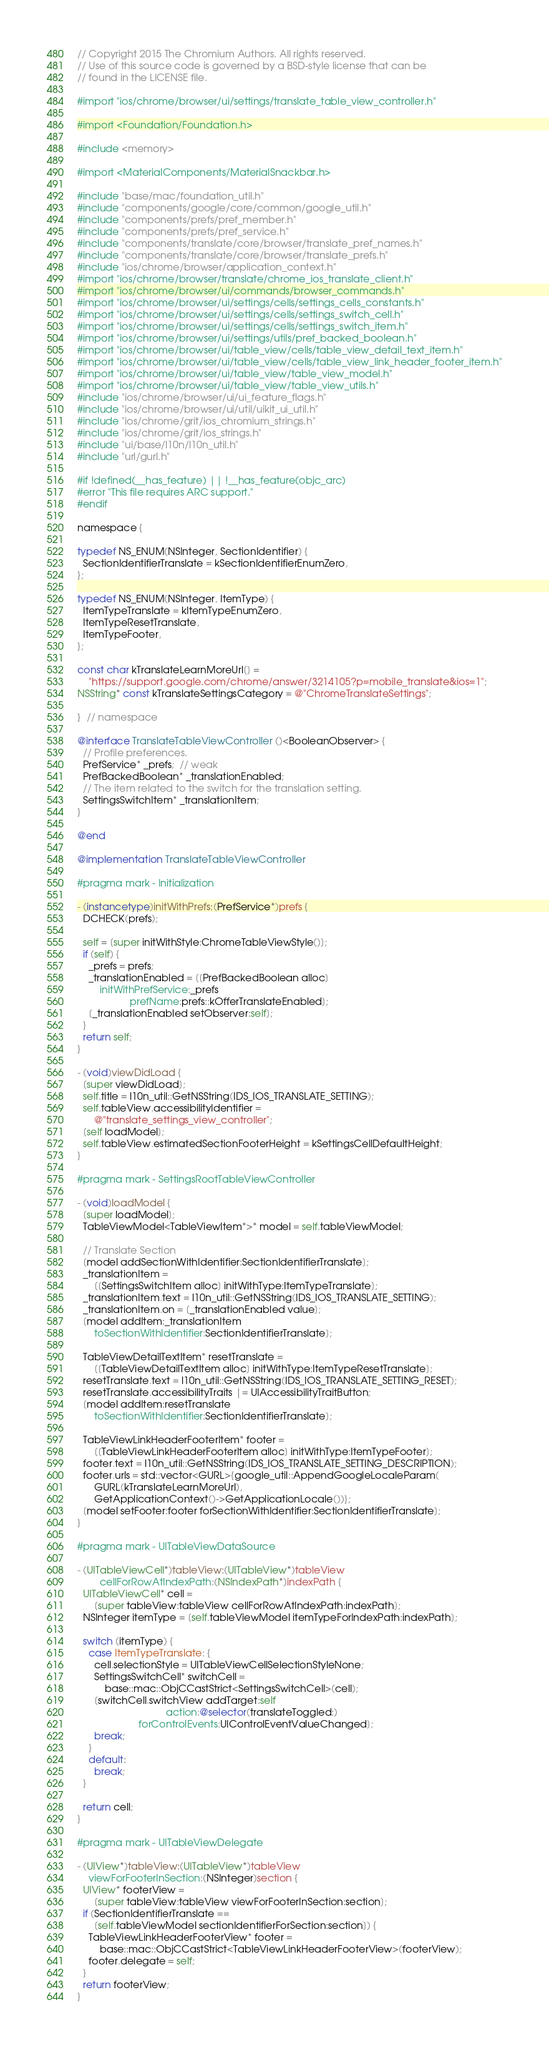Convert code to text. <code><loc_0><loc_0><loc_500><loc_500><_ObjectiveC_>// Copyright 2015 The Chromium Authors. All rights reserved.
// Use of this source code is governed by a BSD-style license that can be
// found in the LICENSE file.

#import "ios/chrome/browser/ui/settings/translate_table_view_controller.h"

#import <Foundation/Foundation.h>

#include <memory>

#import <MaterialComponents/MaterialSnackbar.h>

#include "base/mac/foundation_util.h"
#include "components/google/core/common/google_util.h"
#include "components/prefs/pref_member.h"
#include "components/prefs/pref_service.h"
#include "components/translate/core/browser/translate_pref_names.h"
#include "components/translate/core/browser/translate_prefs.h"
#include "ios/chrome/browser/application_context.h"
#import "ios/chrome/browser/translate/chrome_ios_translate_client.h"
#import "ios/chrome/browser/ui/commands/browser_commands.h"
#import "ios/chrome/browser/ui/settings/cells/settings_cells_constants.h"
#import "ios/chrome/browser/ui/settings/cells/settings_switch_cell.h"
#import "ios/chrome/browser/ui/settings/cells/settings_switch_item.h"
#import "ios/chrome/browser/ui/settings/utils/pref_backed_boolean.h"
#import "ios/chrome/browser/ui/table_view/cells/table_view_detail_text_item.h"
#import "ios/chrome/browser/ui/table_view/cells/table_view_link_header_footer_item.h"
#import "ios/chrome/browser/ui/table_view/table_view_model.h"
#import "ios/chrome/browser/ui/table_view/table_view_utils.h"
#include "ios/chrome/browser/ui/ui_feature_flags.h"
#include "ios/chrome/browser/ui/util/uikit_ui_util.h"
#include "ios/chrome/grit/ios_chromium_strings.h"
#include "ios/chrome/grit/ios_strings.h"
#include "ui/base/l10n/l10n_util.h"
#include "url/gurl.h"

#if !defined(__has_feature) || !__has_feature(objc_arc)
#error "This file requires ARC support."
#endif

namespace {

typedef NS_ENUM(NSInteger, SectionIdentifier) {
  SectionIdentifierTranslate = kSectionIdentifierEnumZero,
};

typedef NS_ENUM(NSInteger, ItemType) {
  ItemTypeTranslate = kItemTypeEnumZero,
  ItemTypeResetTranslate,
  ItemTypeFooter,
};

const char kTranslateLearnMoreUrl[] =
    "https://support.google.com/chrome/answer/3214105?p=mobile_translate&ios=1";
NSString* const kTranslateSettingsCategory = @"ChromeTranslateSettings";

}  // namespace

@interface TranslateTableViewController ()<BooleanObserver> {
  // Profile preferences.
  PrefService* _prefs;  // weak
  PrefBackedBoolean* _translationEnabled;
  // The item related to the switch for the translation setting.
  SettingsSwitchItem* _translationItem;
}

@end

@implementation TranslateTableViewController

#pragma mark - Initialization

- (instancetype)initWithPrefs:(PrefService*)prefs {
  DCHECK(prefs);

  self = [super initWithStyle:ChromeTableViewStyle()];
  if (self) {
    _prefs = prefs;
    _translationEnabled = [[PrefBackedBoolean alloc]
        initWithPrefService:_prefs
                   prefName:prefs::kOfferTranslateEnabled];
    [_translationEnabled setObserver:self];
  }
  return self;
}

- (void)viewDidLoad {
  [super viewDidLoad];
  self.title = l10n_util::GetNSString(IDS_IOS_TRANSLATE_SETTING);
  self.tableView.accessibilityIdentifier =
      @"translate_settings_view_controller";
  [self loadModel];
  self.tableView.estimatedSectionFooterHeight = kSettingsCellDefaultHeight;
}

#pragma mark - SettingsRootTableViewController

- (void)loadModel {
  [super loadModel];
  TableViewModel<TableViewItem*>* model = self.tableViewModel;

  // Translate Section
  [model addSectionWithIdentifier:SectionIdentifierTranslate];
  _translationItem =
      [[SettingsSwitchItem alloc] initWithType:ItemTypeTranslate];
  _translationItem.text = l10n_util::GetNSString(IDS_IOS_TRANSLATE_SETTING);
  _translationItem.on = [_translationEnabled value];
  [model addItem:_translationItem
      toSectionWithIdentifier:SectionIdentifierTranslate];

  TableViewDetailTextItem* resetTranslate =
      [[TableViewDetailTextItem alloc] initWithType:ItemTypeResetTranslate];
  resetTranslate.text = l10n_util::GetNSString(IDS_IOS_TRANSLATE_SETTING_RESET);
  resetTranslate.accessibilityTraits |= UIAccessibilityTraitButton;
  [model addItem:resetTranslate
      toSectionWithIdentifier:SectionIdentifierTranslate];

  TableViewLinkHeaderFooterItem* footer =
      [[TableViewLinkHeaderFooterItem alloc] initWithType:ItemTypeFooter];
  footer.text = l10n_util::GetNSString(IDS_IOS_TRANSLATE_SETTING_DESCRIPTION);
  footer.urls = std::vector<GURL>{google_util::AppendGoogleLocaleParam(
      GURL(kTranslateLearnMoreUrl),
      GetApplicationContext()->GetApplicationLocale())};
  [model setFooter:footer forSectionWithIdentifier:SectionIdentifierTranslate];
}

#pragma mark - UITableViewDataSource

- (UITableViewCell*)tableView:(UITableView*)tableView
        cellForRowAtIndexPath:(NSIndexPath*)indexPath {
  UITableViewCell* cell =
      [super tableView:tableView cellForRowAtIndexPath:indexPath];
  NSInteger itemType = [self.tableViewModel itemTypeForIndexPath:indexPath];

  switch (itemType) {
    case ItemTypeTranslate: {
      cell.selectionStyle = UITableViewCellSelectionStyleNone;
      SettingsSwitchCell* switchCell =
          base::mac::ObjCCastStrict<SettingsSwitchCell>(cell);
      [switchCell.switchView addTarget:self
                                action:@selector(translateToggled:)
                      forControlEvents:UIControlEventValueChanged];
      break;
    }
    default:
      break;
  }

  return cell;
}

#pragma mark - UITableViewDelegate

- (UIView*)tableView:(UITableView*)tableView
    viewForFooterInSection:(NSInteger)section {
  UIView* footerView =
      [super tableView:tableView viewForFooterInSection:section];
  if (SectionIdentifierTranslate ==
      [self.tableViewModel sectionIdentifierForSection:section]) {
    TableViewLinkHeaderFooterView* footer =
        base::mac::ObjCCastStrict<TableViewLinkHeaderFooterView>(footerView);
    footer.delegate = self;
  }
  return footerView;
}
</code> 